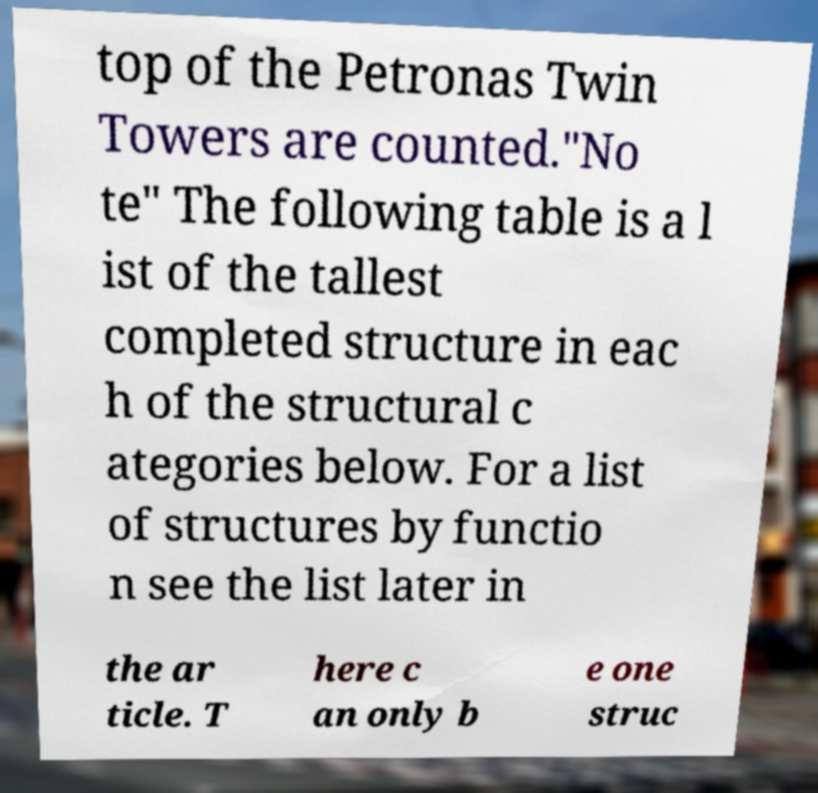Could you extract and type out the text from this image? top of the Petronas Twin Towers are counted."No te" The following table is a l ist of the tallest completed structure in eac h of the structural c ategories below. For a list of structures by functio n see the list later in the ar ticle. T here c an only b e one struc 